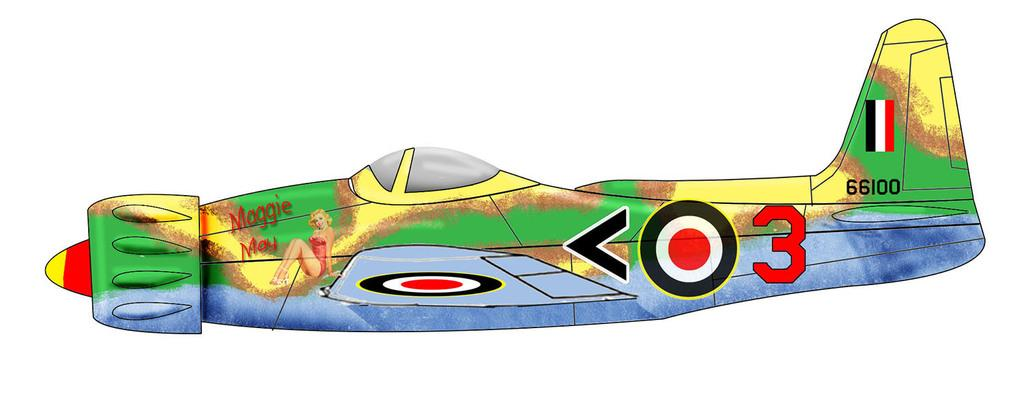What type of image is being described? The image is animated. What is the main subject of the animated image? There is an airplane in the image. Are there any unique features on the airplane? Yes, the airplane has paintings on it. What type of wool is being used to create the airplane in the image? The image is animated, not made of wool, so there is no wool being used to create the airplane. 